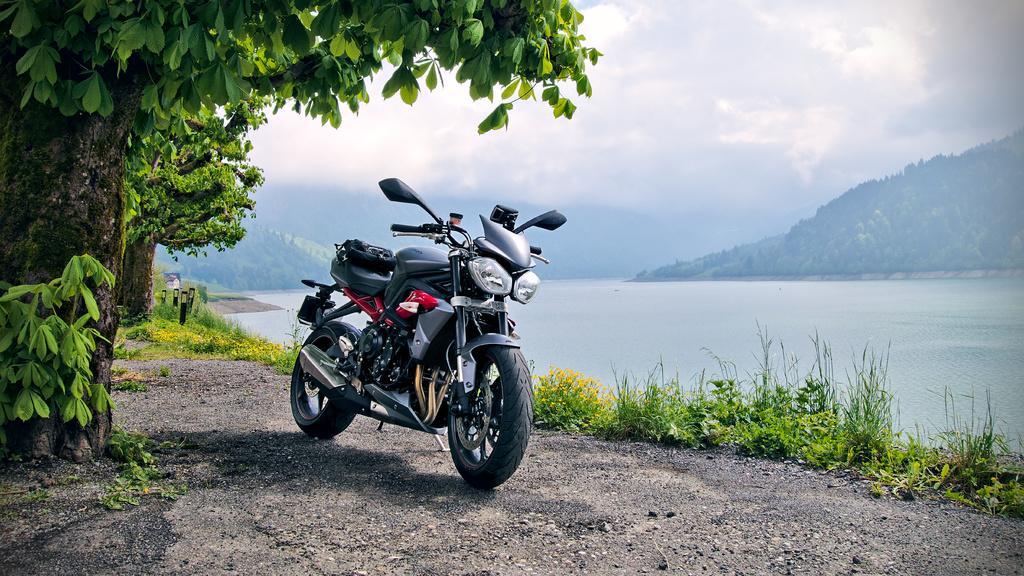Please provide a concise description of this image. In this image I can see the ground, a motor bike which is red, black and grey in color on the ground and few trees which are green and black in color. I can see few black colored poles, some grass, few flowers which are yellow in color and in the background I can see the water, few mountains and the sky. 